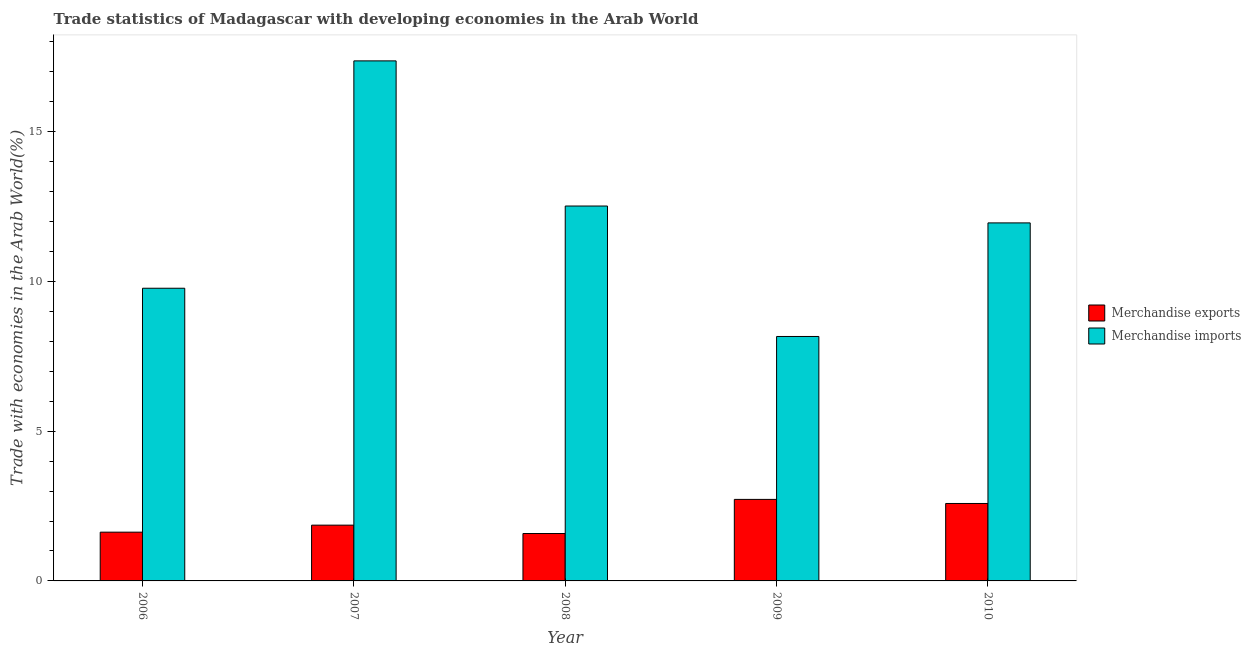How many different coloured bars are there?
Offer a very short reply. 2. Are the number of bars on each tick of the X-axis equal?
Your response must be concise. Yes. How many bars are there on the 2nd tick from the right?
Offer a terse response. 2. What is the label of the 5th group of bars from the left?
Provide a succinct answer. 2010. What is the merchandise imports in 2009?
Provide a short and direct response. 8.16. Across all years, what is the maximum merchandise exports?
Provide a short and direct response. 2.72. Across all years, what is the minimum merchandise imports?
Provide a short and direct response. 8.16. What is the total merchandise imports in the graph?
Provide a succinct answer. 59.77. What is the difference between the merchandise exports in 2006 and that in 2010?
Make the answer very short. -0.96. What is the difference between the merchandise exports in 2006 and the merchandise imports in 2009?
Your answer should be very brief. -1.09. What is the average merchandise exports per year?
Keep it short and to the point. 2.08. What is the ratio of the merchandise imports in 2007 to that in 2009?
Keep it short and to the point. 2.13. What is the difference between the highest and the second highest merchandise imports?
Your answer should be compact. 4.85. What is the difference between the highest and the lowest merchandise exports?
Keep it short and to the point. 1.14. What does the 2nd bar from the right in 2007 represents?
Your response must be concise. Merchandise exports. How many bars are there?
Provide a succinct answer. 10. What is the difference between two consecutive major ticks on the Y-axis?
Your response must be concise. 5. Does the graph contain grids?
Your answer should be compact. No. Where does the legend appear in the graph?
Provide a succinct answer. Center right. How many legend labels are there?
Your answer should be compact. 2. How are the legend labels stacked?
Keep it short and to the point. Vertical. What is the title of the graph?
Ensure brevity in your answer.  Trade statistics of Madagascar with developing economies in the Arab World. What is the label or title of the Y-axis?
Give a very brief answer. Trade with economies in the Arab World(%). What is the Trade with economies in the Arab World(%) of Merchandise exports in 2006?
Make the answer very short. 1.63. What is the Trade with economies in the Arab World(%) in Merchandise imports in 2006?
Ensure brevity in your answer.  9.77. What is the Trade with economies in the Arab World(%) in Merchandise exports in 2007?
Give a very brief answer. 1.86. What is the Trade with economies in the Arab World(%) in Merchandise imports in 2007?
Your answer should be very brief. 17.36. What is the Trade with economies in the Arab World(%) of Merchandise exports in 2008?
Your answer should be very brief. 1.58. What is the Trade with economies in the Arab World(%) of Merchandise imports in 2008?
Ensure brevity in your answer.  12.52. What is the Trade with economies in the Arab World(%) of Merchandise exports in 2009?
Offer a very short reply. 2.72. What is the Trade with economies in the Arab World(%) in Merchandise imports in 2009?
Your response must be concise. 8.16. What is the Trade with economies in the Arab World(%) of Merchandise exports in 2010?
Your response must be concise. 2.59. What is the Trade with economies in the Arab World(%) of Merchandise imports in 2010?
Your answer should be compact. 11.95. Across all years, what is the maximum Trade with economies in the Arab World(%) of Merchandise exports?
Offer a terse response. 2.72. Across all years, what is the maximum Trade with economies in the Arab World(%) of Merchandise imports?
Offer a very short reply. 17.36. Across all years, what is the minimum Trade with economies in the Arab World(%) in Merchandise exports?
Offer a very short reply. 1.58. Across all years, what is the minimum Trade with economies in the Arab World(%) in Merchandise imports?
Make the answer very short. 8.16. What is the total Trade with economies in the Arab World(%) of Merchandise exports in the graph?
Provide a succinct answer. 10.38. What is the total Trade with economies in the Arab World(%) in Merchandise imports in the graph?
Provide a short and direct response. 59.77. What is the difference between the Trade with economies in the Arab World(%) of Merchandise exports in 2006 and that in 2007?
Your response must be concise. -0.23. What is the difference between the Trade with economies in the Arab World(%) of Merchandise imports in 2006 and that in 2007?
Keep it short and to the point. -7.59. What is the difference between the Trade with economies in the Arab World(%) of Merchandise exports in 2006 and that in 2008?
Your response must be concise. 0.05. What is the difference between the Trade with economies in the Arab World(%) in Merchandise imports in 2006 and that in 2008?
Give a very brief answer. -2.75. What is the difference between the Trade with economies in the Arab World(%) in Merchandise exports in 2006 and that in 2009?
Provide a succinct answer. -1.09. What is the difference between the Trade with economies in the Arab World(%) in Merchandise imports in 2006 and that in 2009?
Offer a terse response. 1.61. What is the difference between the Trade with economies in the Arab World(%) of Merchandise exports in 2006 and that in 2010?
Your response must be concise. -0.96. What is the difference between the Trade with economies in the Arab World(%) of Merchandise imports in 2006 and that in 2010?
Offer a very short reply. -2.18. What is the difference between the Trade with economies in the Arab World(%) in Merchandise exports in 2007 and that in 2008?
Your answer should be compact. 0.28. What is the difference between the Trade with economies in the Arab World(%) of Merchandise imports in 2007 and that in 2008?
Provide a succinct answer. 4.85. What is the difference between the Trade with economies in the Arab World(%) of Merchandise exports in 2007 and that in 2009?
Ensure brevity in your answer.  -0.86. What is the difference between the Trade with economies in the Arab World(%) of Merchandise imports in 2007 and that in 2009?
Keep it short and to the point. 9.2. What is the difference between the Trade with economies in the Arab World(%) of Merchandise exports in 2007 and that in 2010?
Your answer should be compact. -0.72. What is the difference between the Trade with economies in the Arab World(%) of Merchandise imports in 2007 and that in 2010?
Your answer should be compact. 5.41. What is the difference between the Trade with economies in the Arab World(%) in Merchandise exports in 2008 and that in 2009?
Keep it short and to the point. -1.14. What is the difference between the Trade with economies in the Arab World(%) of Merchandise imports in 2008 and that in 2009?
Keep it short and to the point. 4.36. What is the difference between the Trade with economies in the Arab World(%) of Merchandise exports in 2008 and that in 2010?
Make the answer very short. -1. What is the difference between the Trade with economies in the Arab World(%) of Merchandise imports in 2008 and that in 2010?
Your answer should be compact. 0.56. What is the difference between the Trade with economies in the Arab World(%) in Merchandise exports in 2009 and that in 2010?
Give a very brief answer. 0.14. What is the difference between the Trade with economies in the Arab World(%) of Merchandise imports in 2009 and that in 2010?
Make the answer very short. -3.79. What is the difference between the Trade with economies in the Arab World(%) of Merchandise exports in 2006 and the Trade with economies in the Arab World(%) of Merchandise imports in 2007?
Give a very brief answer. -15.73. What is the difference between the Trade with economies in the Arab World(%) in Merchandise exports in 2006 and the Trade with economies in the Arab World(%) in Merchandise imports in 2008?
Provide a short and direct response. -10.89. What is the difference between the Trade with economies in the Arab World(%) of Merchandise exports in 2006 and the Trade with economies in the Arab World(%) of Merchandise imports in 2009?
Give a very brief answer. -6.53. What is the difference between the Trade with economies in the Arab World(%) of Merchandise exports in 2006 and the Trade with economies in the Arab World(%) of Merchandise imports in 2010?
Provide a succinct answer. -10.33. What is the difference between the Trade with economies in the Arab World(%) in Merchandise exports in 2007 and the Trade with economies in the Arab World(%) in Merchandise imports in 2008?
Your answer should be very brief. -10.65. What is the difference between the Trade with economies in the Arab World(%) of Merchandise exports in 2007 and the Trade with economies in the Arab World(%) of Merchandise imports in 2009?
Make the answer very short. -6.3. What is the difference between the Trade with economies in the Arab World(%) of Merchandise exports in 2007 and the Trade with economies in the Arab World(%) of Merchandise imports in 2010?
Provide a succinct answer. -10.09. What is the difference between the Trade with economies in the Arab World(%) in Merchandise exports in 2008 and the Trade with economies in the Arab World(%) in Merchandise imports in 2009?
Provide a succinct answer. -6.58. What is the difference between the Trade with economies in the Arab World(%) in Merchandise exports in 2008 and the Trade with economies in the Arab World(%) in Merchandise imports in 2010?
Offer a terse response. -10.37. What is the difference between the Trade with economies in the Arab World(%) in Merchandise exports in 2009 and the Trade with economies in the Arab World(%) in Merchandise imports in 2010?
Make the answer very short. -9.23. What is the average Trade with economies in the Arab World(%) of Merchandise exports per year?
Provide a short and direct response. 2.08. What is the average Trade with economies in the Arab World(%) of Merchandise imports per year?
Keep it short and to the point. 11.95. In the year 2006, what is the difference between the Trade with economies in the Arab World(%) in Merchandise exports and Trade with economies in the Arab World(%) in Merchandise imports?
Keep it short and to the point. -8.14. In the year 2007, what is the difference between the Trade with economies in the Arab World(%) in Merchandise exports and Trade with economies in the Arab World(%) in Merchandise imports?
Ensure brevity in your answer.  -15.5. In the year 2008, what is the difference between the Trade with economies in the Arab World(%) in Merchandise exports and Trade with economies in the Arab World(%) in Merchandise imports?
Make the answer very short. -10.93. In the year 2009, what is the difference between the Trade with economies in the Arab World(%) of Merchandise exports and Trade with economies in the Arab World(%) of Merchandise imports?
Give a very brief answer. -5.44. In the year 2010, what is the difference between the Trade with economies in the Arab World(%) of Merchandise exports and Trade with economies in the Arab World(%) of Merchandise imports?
Your answer should be compact. -9.37. What is the ratio of the Trade with economies in the Arab World(%) in Merchandise exports in 2006 to that in 2007?
Make the answer very short. 0.87. What is the ratio of the Trade with economies in the Arab World(%) of Merchandise imports in 2006 to that in 2007?
Offer a terse response. 0.56. What is the ratio of the Trade with economies in the Arab World(%) of Merchandise exports in 2006 to that in 2008?
Offer a terse response. 1.03. What is the ratio of the Trade with economies in the Arab World(%) of Merchandise imports in 2006 to that in 2008?
Offer a terse response. 0.78. What is the ratio of the Trade with economies in the Arab World(%) of Merchandise exports in 2006 to that in 2009?
Your response must be concise. 0.6. What is the ratio of the Trade with economies in the Arab World(%) in Merchandise imports in 2006 to that in 2009?
Offer a very short reply. 1.2. What is the ratio of the Trade with economies in the Arab World(%) in Merchandise exports in 2006 to that in 2010?
Offer a terse response. 0.63. What is the ratio of the Trade with economies in the Arab World(%) of Merchandise imports in 2006 to that in 2010?
Your answer should be compact. 0.82. What is the ratio of the Trade with economies in the Arab World(%) in Merchandise exports in 2007 to that in 2008?
Give a very brief answer. 1.18. What is the ratio of the Trade with economies in the Arab World(%) of Merchandise imports in 2007 to that in 2008?
Your answer should be compact. 1.39. What is the ratio of the Trade with economies in the Arab World(%) in Merchandise exports in 2007 to that in 2009?
Give a very brief answer. 0.68. What is the ratio of the Trade with economies in the Arab World(%) in Merchandise imports in 2007 to that in 2009?
Keep it short and to the point. 2.13. What is the ratio of the Trade with economies in the Arab World(%) of Merchandise exports in 2007 to that in 2010?
Offer a very short reply. 0.72. What is the ratio of the Trade with economies in the Arab World(%) in Merchandise imports in 2007 to that in 2010?
Provide a short and direct response. 1.45. What is the ratio of the Trade with economies in the Arab World(%) in Merchandise exports in 2008 to that in 2009?
Offer a very short reply. 0.58. What is the ratio of the Trade with economies in the Arab World(%) in Merchandise imports in 2008 to that in 2009?
Provide a succinct answer. 1.53. What is the ratio of the Trade with economies in the Arab World(%) in Merchandise exports in 2008 to that in 2010?
Ensure brevity in your answer.  0.61. What is the ratio of the Trade with economies in the Arab World(%) of Merchandise imports in 2008 to that in 2010?
Keep it short and to the point. 1.05. What is the ratio of the Trade with economies in the Arab World(%) of Merchandise exports in 2009 to that in 2010?
Provide a short and direct response. 1.05. What is the ratio of the Trade with economies in the Arab World(%) in Merchandise imports in 2009 to that in 2010?
Your response must be concise. 0.68. What is the difference between the highest and the second highest Trade with economies in the Arab World(%) of Merchandise exports?
Offer a terse response. 0.14. What is the difference between the highest and the second highest Trade with economies in the Arab World(%) of Merchandise imports?
Offer a very short reply. 4.85. What is the difference between the highest and the lowest Trade with economies in the Arab World(%) of Merchandise exports?
Provide a short and direct response. 1.14. What is the difference between the highest and the lowest Trade with economies in the Arab World(%) of Merchandise imports?
Offer a terse response. 9.2. 